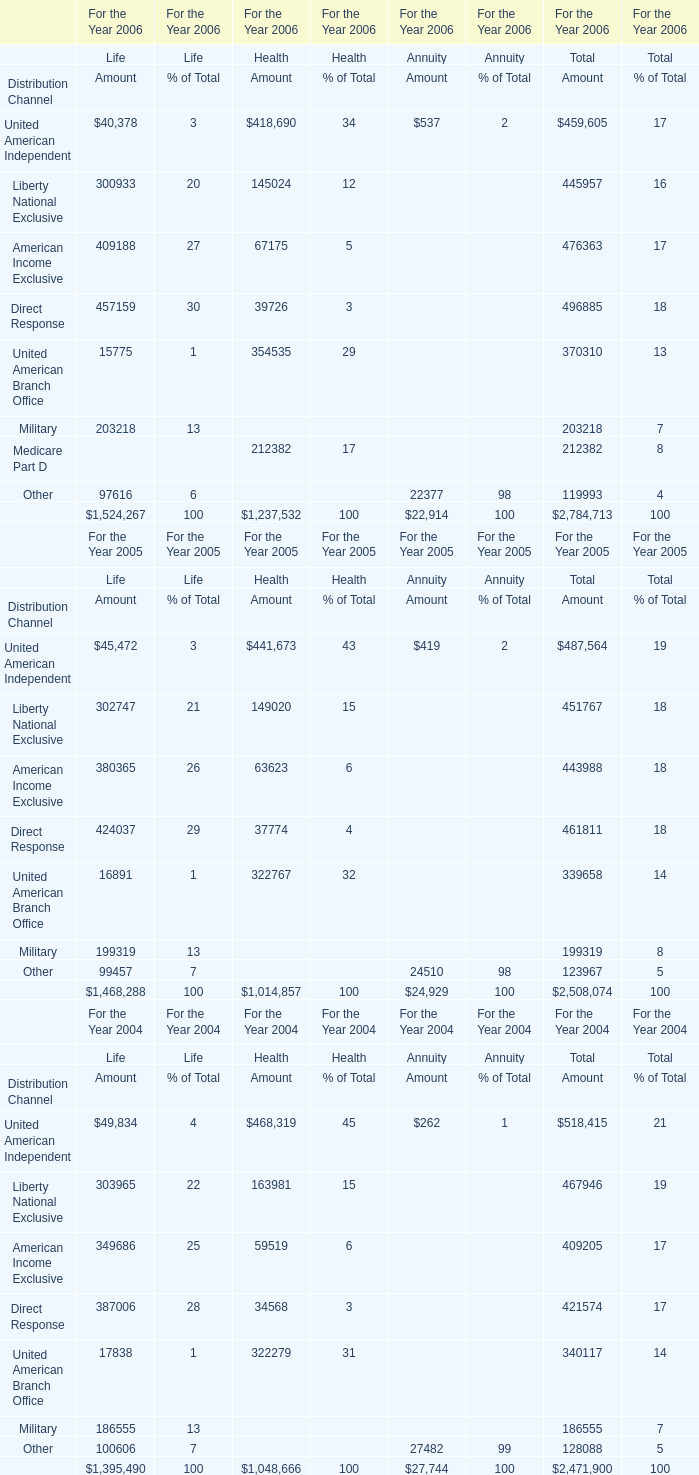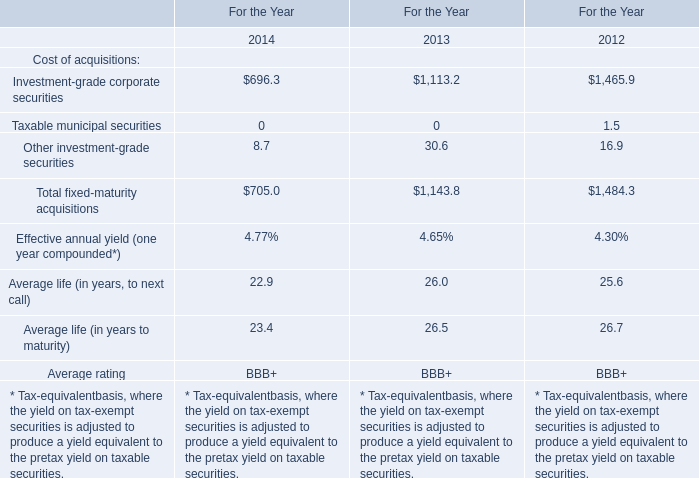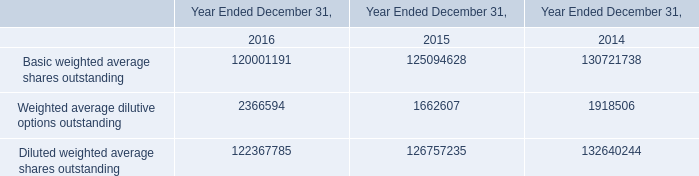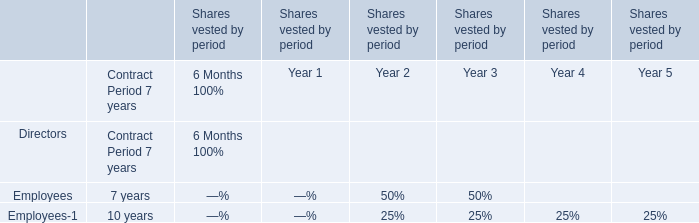What was the total amount of Life in 2006 for Amount? 
Answer: 1524267. 